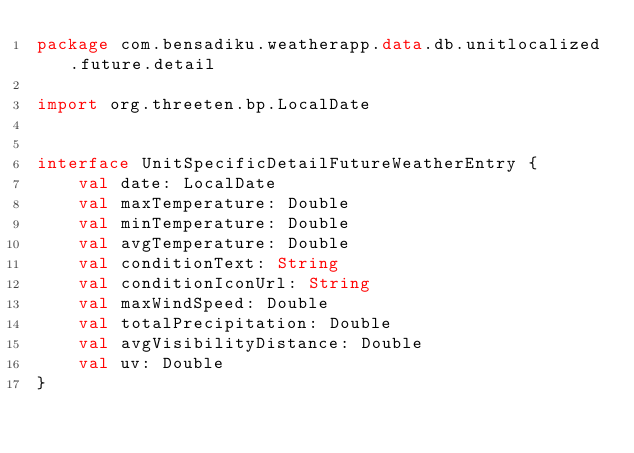Convert code to text. <code><loc_0><loc_0><loc_500><loc_500><_Kotlin_>package com.bensadiku.weatherapp.data.db.unitlocalized.future.detail

import org.threeten.bp.LocalDate


interface UnitSpecificDetailFutureWeatherEntry {
    val date: LocalDate
    val maxTemperature: Double
    val minTemperature: Double
    val avgTemperature: Double
    val conditionText: String
    val conditionIconUrl: String
    val maxWindSpeed: Double
    val totalPrecipitation: Double
    val avgVisibilityDistance: Double
    val uv: Double
}</code> 